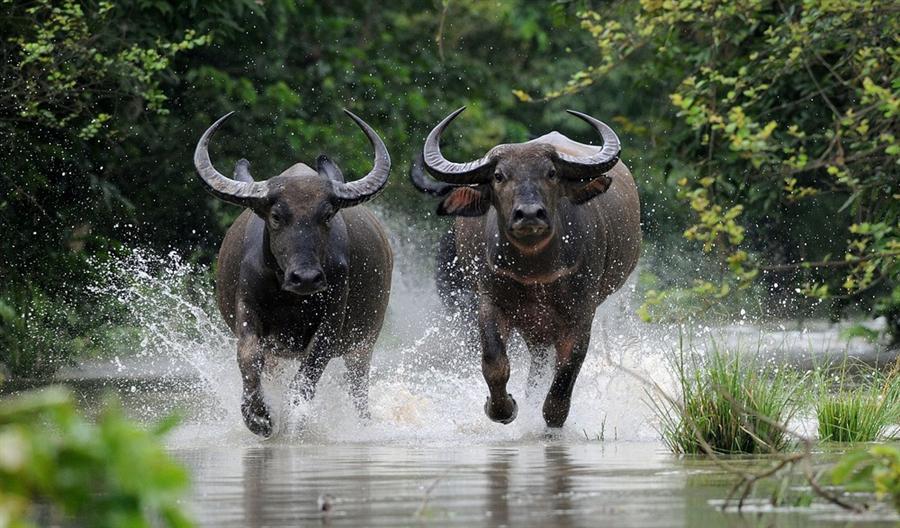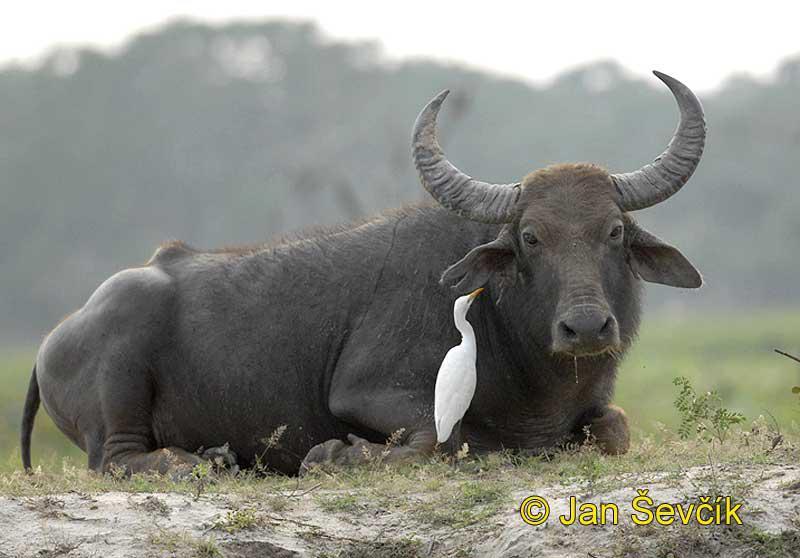The first image is the image on the left, the second image is the image on the right. Analyze the images presented: Is the assertion "One image shows exactly two water buffalo, both in profile." valid? Answer yes or no. No. 